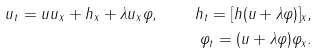<formula> <loc_0><loc_0><loc_500><loc_500>u _ { t } = u u _ { x } + h _ { x } + \lambda u _ { x } \varphi , \quad h _ { t } = [ h ( u + \lambda \varphi ) ] _ { x } , \\ \varphi _ { t } = ( u + \lambda \varphi ) \varphi _ { x } .</formula> 